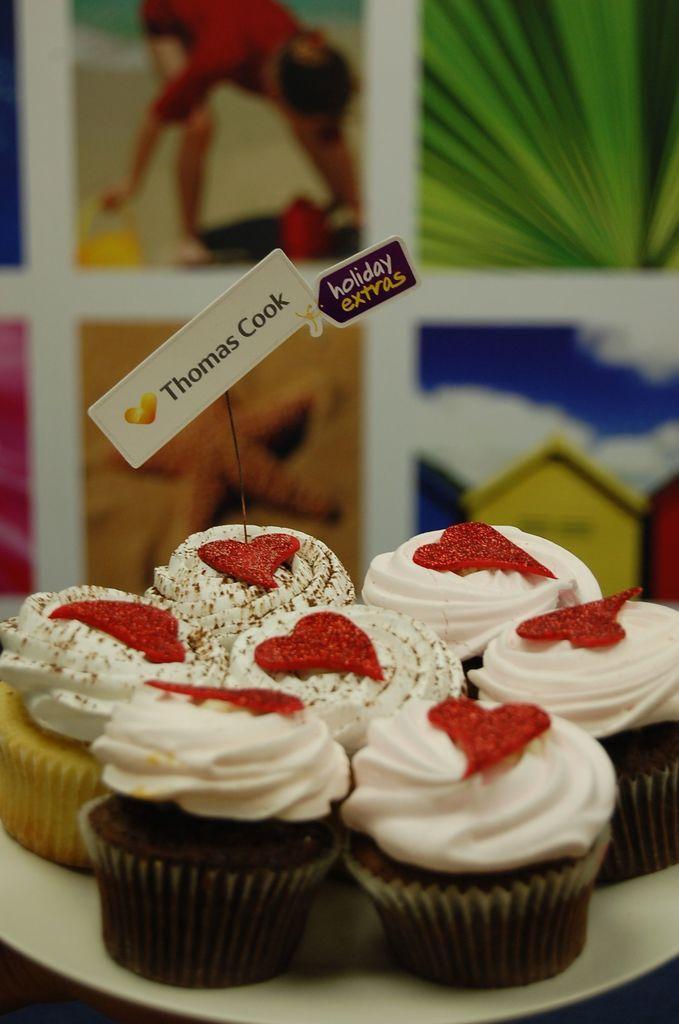Describe this image in one or two sentences. In this image I can see some cupcakes in the plate. In the background, I can see some images. 